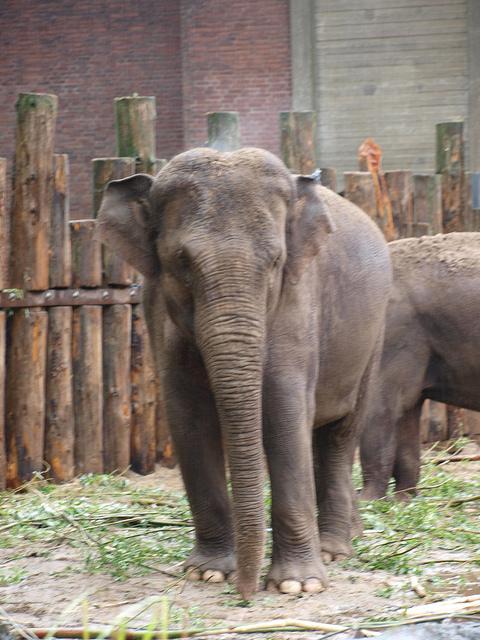What kind of fence is in front of the elephant?
Answer briefly. Wooden. Is the wall made of bricks?
Quick response, please. Yes. Is there a fence in the background?
Answer briefly. Yes. Is the elephant a baby?
Concise answer only. Yes. How many elephants are there?
Keep it brief. 2. 